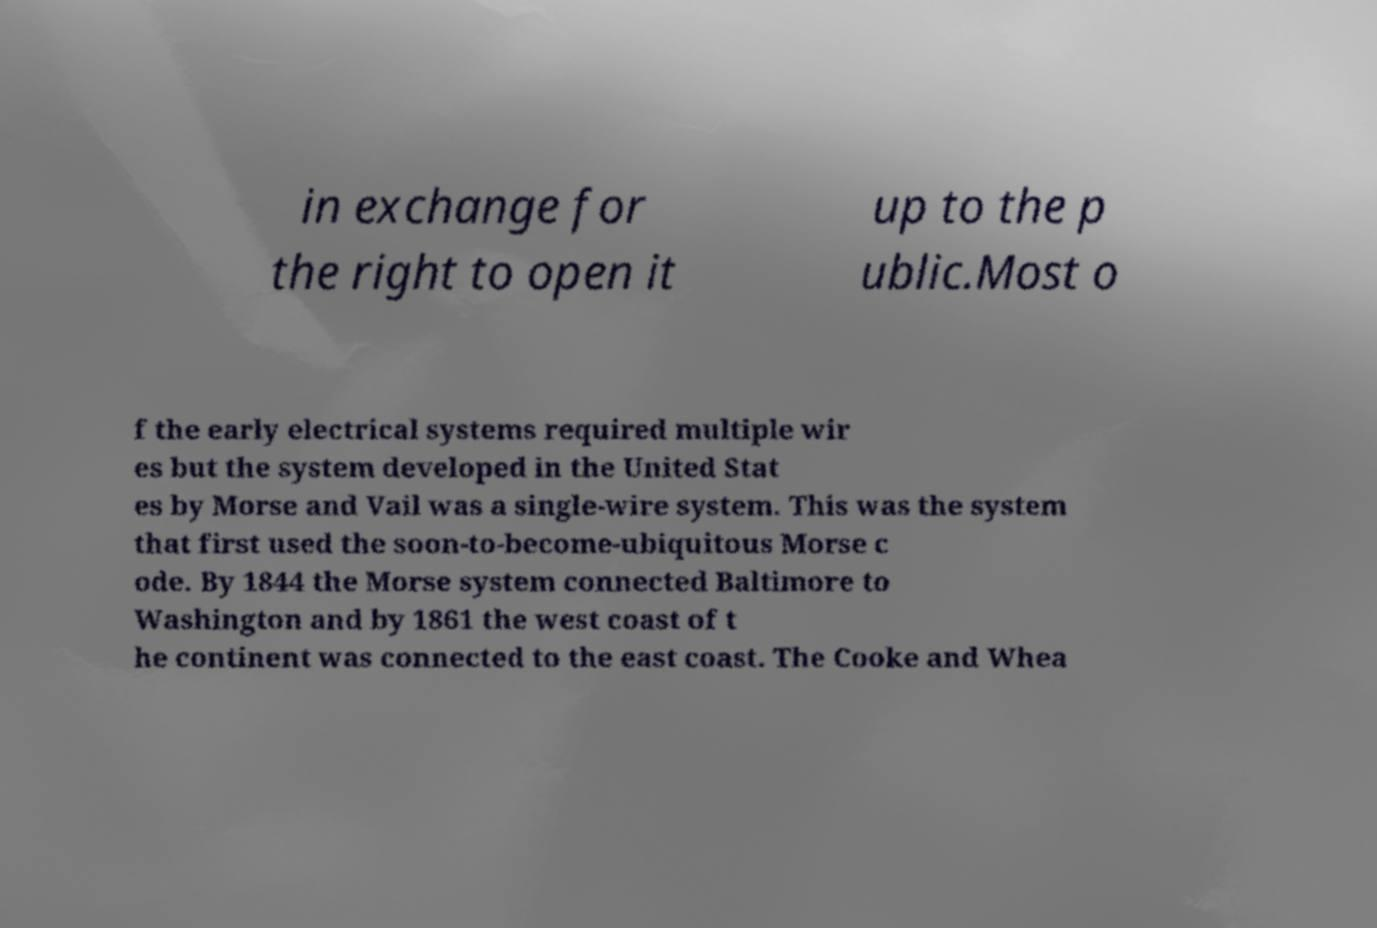Can you accurately transcribe the text from the provided image for me? in exchange for the right to open it up to the p ublic.Most o f the early electrical systems required multiple wir es but the system developed in the United Stat es by Morse and Vail was a single-wire system. This was the system that first used the soon-to-become-ubiquitous Morse c ode. By 1844 the Morse system connected Baltimore to Washington and by 1861 the west coast of t he continent was connected to the east coast. The Cooke and Whea 